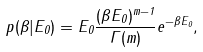<formula> <loc_0><loc_0><loc_500><loc_500>p ( \beta | E _ { 0 } ) = E _ { 0 } \frac { ( \beta E _ { 0 } ) ^ { m - 1 } } { \Gamma ( m ) } e ^ { - \beta E _ { 0 } } ,</formula> 